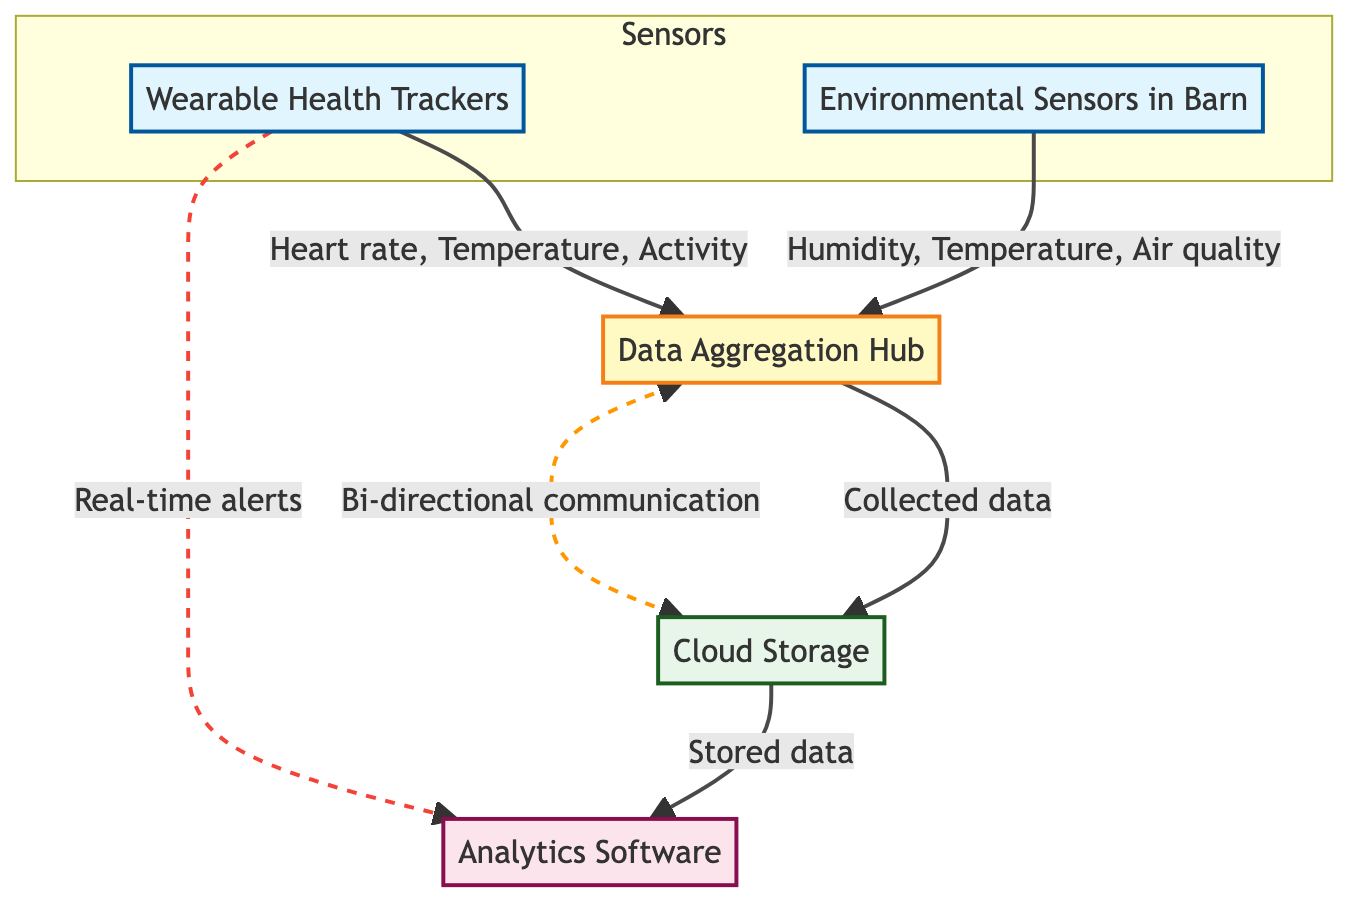What type of devices are included in the Wearable Health Trackers node? The Wearable Health Trackers node lists three devices: FitBark, Moocall, and CowManager. These are explicitly mentioned in the node description.
Answer: FitBark, Moocall, CowManager How many environmental sensors are shown in the diagram? The Environmental Sensors in Barn node includes two specific devices: Allflex SenseHub and Libelium Waspmote, which can be counted in the diagram.
Answer: 2 What metrics are collected by the data aggregation hub? The data aggregation hub collects data from the wearable health trackers and environmental sensors in the barn. These sources are indicated in the data flow section of the diagram.
Answer: Collected data What type of function does the cloud storage provide? Based on the diagram, the cloud storage's function is labeled as "storeData," which indicates its primary role in the system.
Answer: storeData Which software tools are used for analytics in the system? The analytics software node specifies three tools: Tableau, Power BI, and Google Data Studio. These tools are listed in the node description.
Answer: Tableau, Power BI, Google Data Studio What is the relationship between data aggregation hub and cloud storage? The data aggregation hub sends collected data to the cloud storage, as indicated by the unidirectional arrow in the diagram that represents data flow.
Answer: Collected data How do wearable health trackers communicate real-time alerts? Real-time alerts from wearable health trackers are indicated to flow to the analytics software. This is represented by a dashed line in the diagram, indicating a specific communication type.
Answer: Real-time alerts What kind of communication exists between the data aggregation hub and cloud storage? The diagram depicts bi-directional communication between the data aggregation hub and cloud storage, shown with a double-headed arrow, indicating that data can flow in both directions.
Answer: Bi-directional communication Identify the data sources for analytics software. The analytics software receives its data from cloud storage, as outlined in the data flow section of the diagram. This connection is clearly shown with a directed arrow.
Answer: cloudStorage 